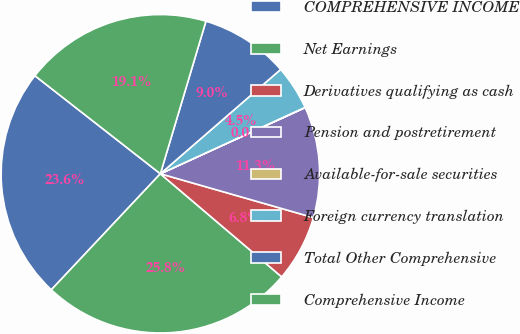Convert chart. <chart><loc_0><loc_0><loc_500><loc_500><pie_chart><fcel>COMPREHENSIVE INCOME<fcel>Net Earnings<fcel>Derivatives qualifying as cash<fcel>Pension and postretirement<fcel>Available-for-sale securities<fcel>Foreign currency translation<fcel>Total Other Comprehensive<fcel>Comprehensive Income<nl><fcel>23.55%<fcel>25.79%<fcel>6.77%<fcel>11.26%<fcel>0.03%<fcel>4.52%<fcel>9.01%<fcel>19.06%<nl></chart> 